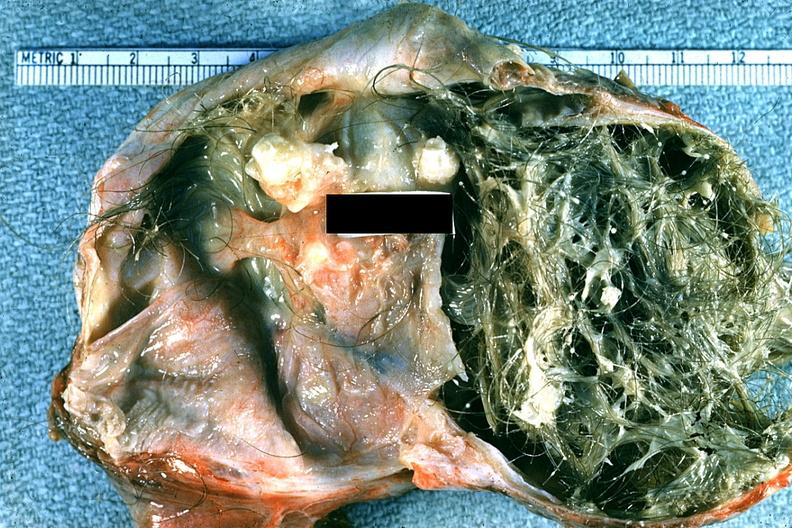s lower chest and abdomen anterior present?
Answer the question using a single word or phrase. No 